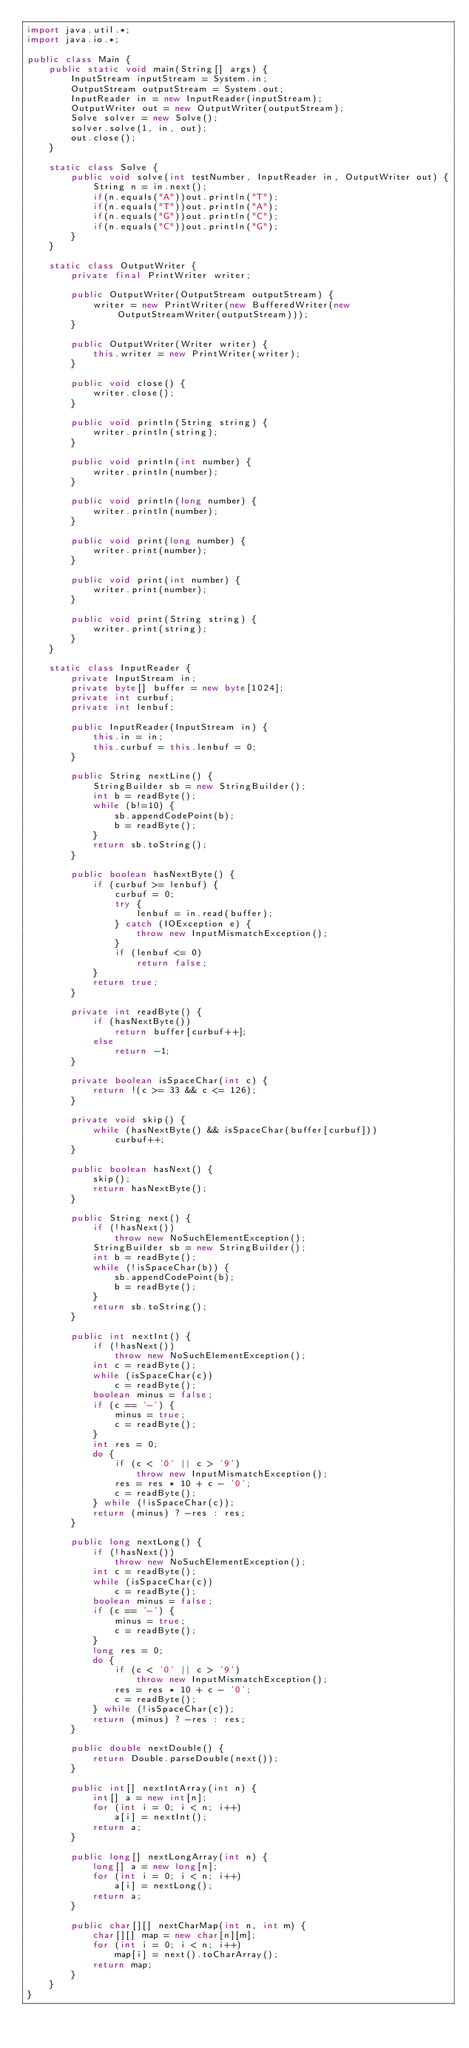Convert code to text. <code><loc_0><loc_0><loc_500><loc_500><_Java_>import java.util.*;
import java.io.*;

public class Main {
    public static void main(String[] args) {
        InputStream inputStream = System.in;
        OutputStream outputStream = System.out;
        InputReader in = new InputReader(inputStream);
        OutputWriter out = new OutputWriter(outputStream);
        Solve solver = new Solve();
        solver.solve(1, in, out);
        out.close();
    }
    
    static class Solve {
    	public void solve(int testNumber, InputReader in, OutputWriter out) {
    		String n = in.next();
    		if(n.equals("A"))out.println("T");
    		if(n.equals("T"))out.println("A");
    		if(n.equals("G"))out.println("C");
    		if(n.equals("C"))out.println("G");
    	}
    }
    
    static class OutputWriter {
	    private final PrintWriter writer;
	
	    public OutputWriter(OutputStream outputStream) {
	        writer = new PrintWriter(new BufferedWriter(new OutputStreamWriter(outputStream)));
	    }
	
	    public OutputWriter(Writer writer) {
	        this.writer = new PrintWriter(writer);
	    }
	
	    public void close() {
	        writer.close();
	    }
	
	    public void println(String string) {
	        writer.println(string);
	    }
	    
	    public void println(int number) {
	        writer.println(number);
	    }
	    
	    public void println(long number) {
	        writer.println(number);
	    }
	    
	    public void print(long number) {
	        writer.print(number);
	    }
	    
	    public void print(int number) {
	        writer.print(number);
	    }
	    
	    public void print(String string) {
	        writer.print(string);
	    }
	}
    
	static class InputReader { 
		private InputStream in;
		private byte[] buffer = new byte[1024];
		private int curbuf;
		private int lenbuf;
		
		public InputReader(InputStream in) {
			this.in = in;
			this.curbuf = this.lenbuf = 0;
		}
		
		public String nextLine() {
			StringBuilder sb = new StringBuilder();
			int b = readByte();
			while (b!=10) {
				sb.appendCodePoint(b);
				b = readByte();
			}
			return sb.toString();
		}
		
		public boolean hasNextByte() {
			if (curbuf >= lenbuf) {
				curbuf = 0;
				try {
					lenbuf = in.read(buffer);
				} catch (IOException e) {
					throw new InputMismatchException();
				}
				if (lenbuf <= 0)
					return false;
			}
			return true;
		}
 
		private int readByte() {
			if (hasNextByte())
				return buffer[curbuf++];
			else
				return -1;
		}
 
		private boolean isSpaceChar(int c) {
			return !(c >= 33 && c <= 126);
		}
 
		private void skip() {
			while (hasNextByte() && isSpaceChar(buffer[curbuf]))
				curbuf++;
		}
 
		public boolean hasNext() {
			skip();
			return hasNextByte();
		}
 
		public String next() {
			if (!hasNext())
				throw new NoSuchElementException();
			StringBuilder sb = new StringBuilder();
			int b = readByte();
			while (!isSpaceChar(b)) {
				sb.appendCodePoint(b);
				b = readByte();
			}
			return sb.toString();
		}
 
		public int nextInt() {
			if (!hasNext())
				throw new NoSuchElementException();
			int c = readByte();
			while (isSpaceChar(c))
				c = readByte();
			boolean minus = false;
			if (c == '-') {
				minus = true;
				c = readByte();
			}
			int res = 0;
			do {
				if (c < '0' || c > '9')
					throw new InputMismatchException();
				res = res * 10 + c - '0';
				c = readByte();
			} while (!isSpaceChar(c));
			return (minus) ? -res : res;
		}
 
		public long nextLong() {
			if (!hasNext())
				throw new NoSuchElementException();
			int c = readByte();
			while (isSpaceChar(c))
				c = readByte();
			boolean minus = false;
			if (c == '-') {
				minus = true;
				c = readByte();
			}
			long res = 0;
			do {
				if (c < '0' || c > '9')
					throw new InputMismatchException();
				res = res * 10 + c - '0';
				c = readByte();
			} while (!isSpaceChar(c));
			return (minus) ? -res : res;
		}
		
		public double nextDouble() {
			return Double.parseDouble(next());
		}
 
		public int[] nextIntArray(int n) {
			int[] a = new int[n];
			for (int i = 0; i < n; i++)
				a[i] = nextInt();
			return a;
		}
 
		public long[] nextLongArray(int n) {
			long[] a = new long[n];
			for (int i = 0; i < n; i++)
				a[i] = nextLong();
			return a;
		}
 
		public char[][] nextCharMap(int n, int m) {
			char[][] map = new char[n][m];
			for (int i = 0; i < n; i++)
				map[i] = next().toCharArray();
			return map;
		}
	}
}</code> 